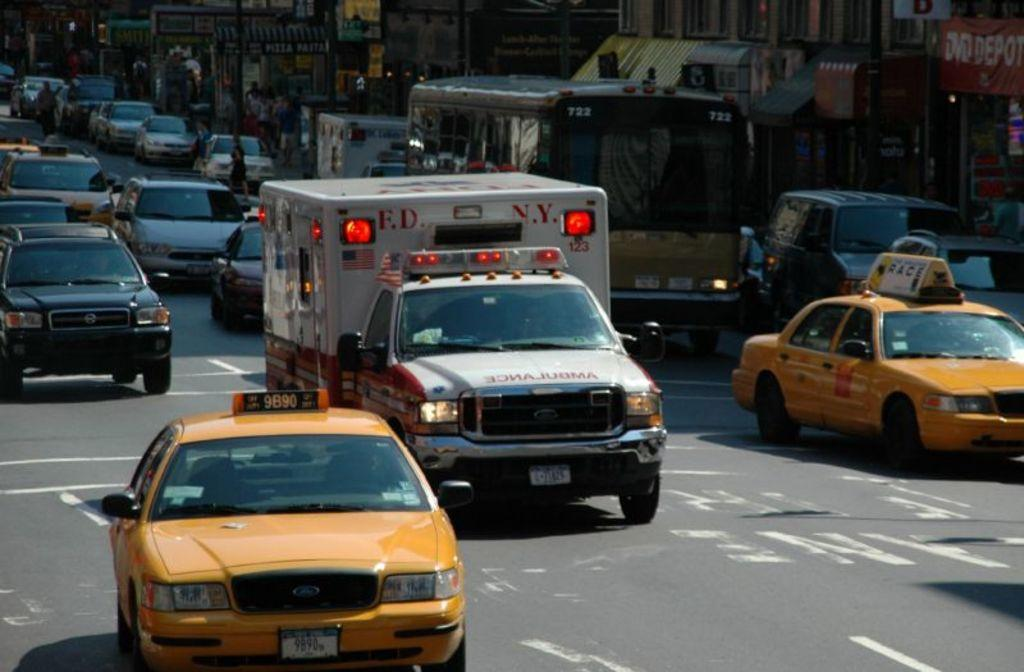<image>
Offer a succinct explanation of the picture presented. An ambulance, from the F.D.N.Y., is going through traffic. 